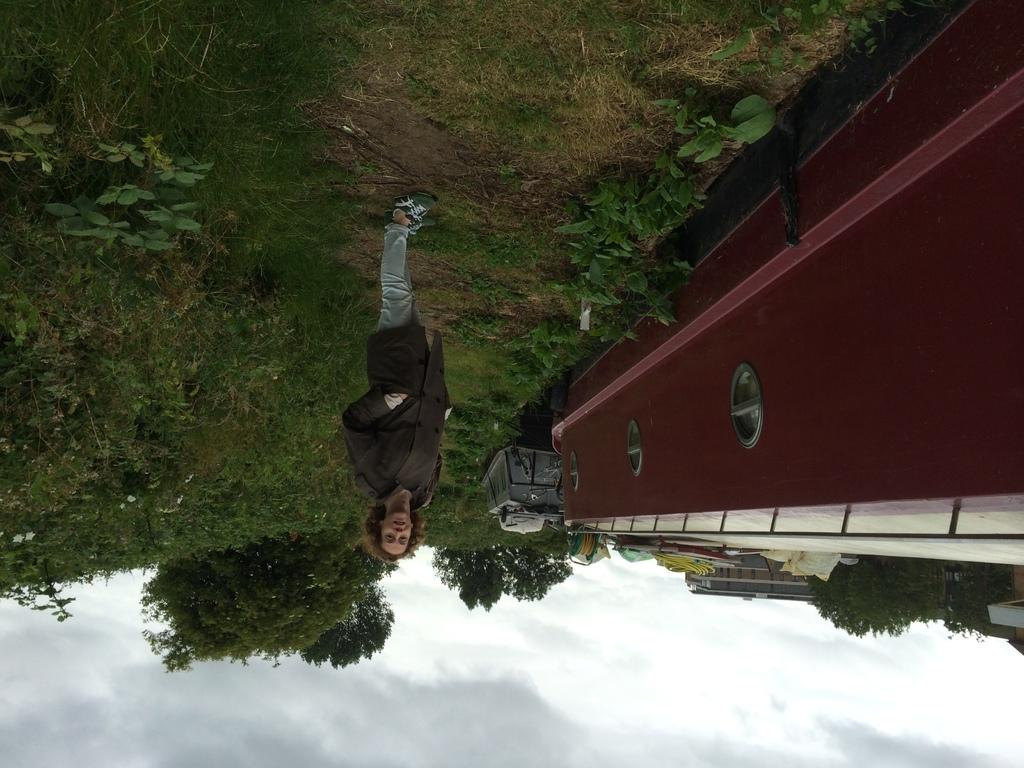How is the orientation of the image? The image is upside down. What can be seen in the image despite its orientation? There is a girl standing on the ground in the image. What type of memory does the girl have in the image? There is no indication of any specific memory in the image; it simply shows a girl standing on the ground. Can you tell me how many geese are present in the image? There are no geese present in the image; it only features a girl standing on the ground. 